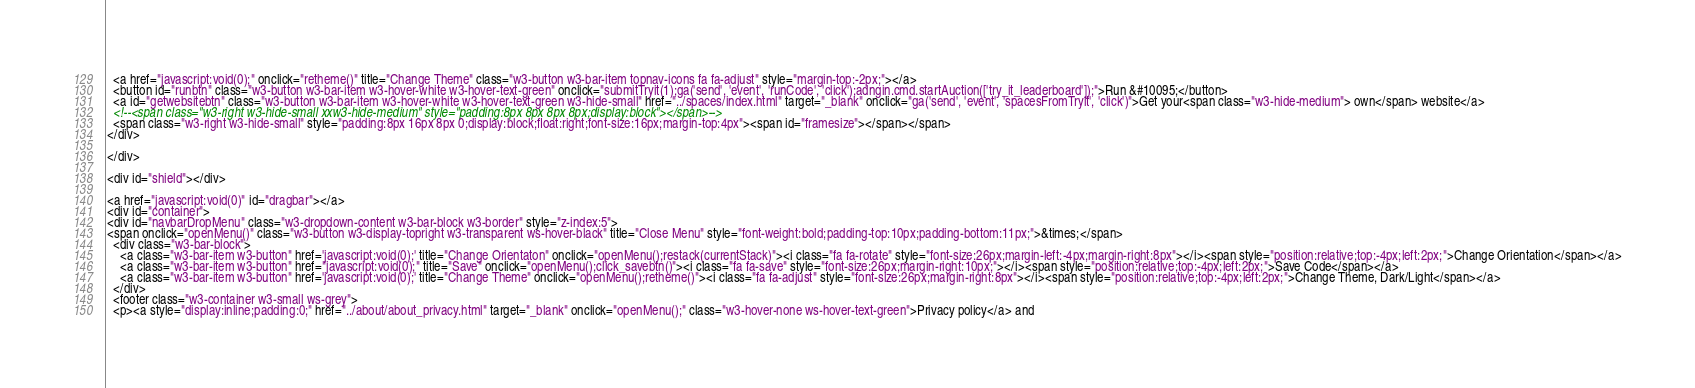Convert code to text. <code><loc_0><loc_0><loc_500><loc_500><_HTML_>  <a href="javascript:void(0);" onclick="retheme()" title="Change Theme" class="w3-button w3-bar-item topnav-icons fa fa-adjust" style="margin-top:-2px;"></a>
  <button id="runbtn" class="w3-button w3-bar-item w3-hover-white w3-hover-text-green" onclick="submitTryit(1);ga('send', 'event', 'runCode', 'click');adngin.cmd.startAuction(['try_it_leaderboard']);">Run &#10095;</button>
  <a id="getwebsitebtn" class="w3-button w3-bar-item w3-hover-white w3-hover-text-green w3-hide-small" href="../spaces/index.html" target="_blank" onclick="ga('send', 'event', 'spacesFromTryit', 'click')">Get your<span class="w3-hide-medium"> own</span> website</a>
  <!--<span class="w3-right w3-hide-small xxw3-hide-medium" style="padding:8px 8px 8px 8px;display:block"></span>-->
  <span class="w3-right w3-hide-small" style="padding:8px 16px 8px 0;display:block;float:right;font-size:16px;margin-top:4px"><span id="framesize"></span></span>
</div>

</div>

<div id="shield"></div>

<a href="javascript:void(0)" id="dragbar"></a>
<div id="container">
<div id="navbarDropMenu" class="w3-dropdown-content w3-bar-block w3-border" style="z-index:5">
<span onclick="openMenu()" class="w3-button w3-display-topright w3-transparent ws-hover-black" title="Close Menu" style="font-weight:bold;padding-top:10px;padding-bottom:11px;">&times;</span>
  <div class="w3-bar-block">
    <a class="w3-bar-item w3-button" href='javascript:void(0);' title="Change Orientaton" onclick="openMenu();restack(currentStack)"><i class="fa fa-rotate" style="font-size:26px;margin-left:-4px;margin-right:8px"></i><span style="position:relative;top:-4px;left:2px;">Change Orientation</span></a>
    <a class="w3-bar-item w3-button" href="javascript:void(0);" title="Save" onclick="openMenu();click_savebtn()"><i class="fa fa-save" style="font-size:26px;margin-right:10px;"></i><span style="position:relative;top:-4px;left:2px;">Save Code</span></a>
    <a class="w3-bar-item w3-button" href='javascript:void(0);' title="Change Theme" onclick="openMenu();retheme()"><i class="fa fa-adjust" style="font-size:26px;margin-right:8px"></i><span style="position:relative;top:-4px;left:2px;">Change Theme, Dark/Light</span></a>
  </div>
  <footer class="w3-container w3-small ws-grey">
  <p><a style="display:inline;padding:0;" href="../about/about_privacy.html" target="_blank" onclick="openMenu();" class="w3-hover-none ws-hover-text-green">Privacy policy</a> and </code> 